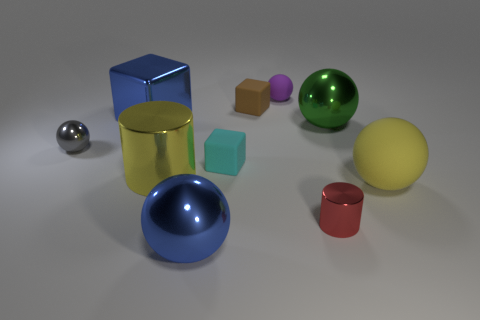How many other things are the same shape as the purple matte thing?
Give a very brief answer. 4. Are there any tiny brown matte cubes in front of the gray sphere?
Offer a terse response. No. The large shiny cylinder has what color?
Offer a terse response. Yellow. Do the small shiny cylinder and the big shiny ball that is to the right of the small brown cube have the same color?
Ensure brevity in your answer.  No. Are there any blocks of the same size as the gray metallic object?
Your response must be concise. Yes. There is a sphere that is the same color as the large cylinder; what size is it?
Provide a succinct answer. Large. What material is the yellow thing that is on the left side of the brown cube?
Your answer should be very brief. Metal. Are there the same number of big green shiny objects left of the tiny metal cylinder and objects that are to the left of the large yellow metal object?
Your answer should be very brief. No. Do the green object that is on the right side of the metal cube and the shiny cylinder that is in front of the large metal cylinder have the same size?
Ensure brevity in your answer.  No. How many large cubes have the same color as the tiny shiny cylinder?
Offer a terse response. 0. 